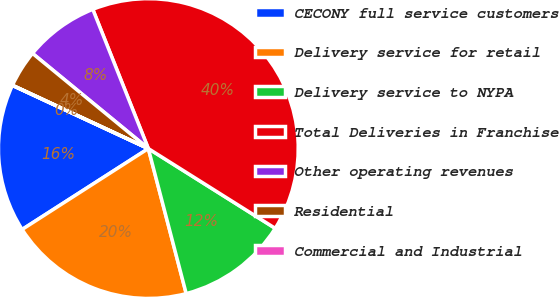<chart> <loc_0><loc_0><loc_500><loc_500><pie_chart><fcel>CECONY full service customers<fcel>Delivery service for retail<fcel>Delivery service to NYPA<fcel>Total Deliveries in Franchise<fcel>Other operating revenues<fcel>Residential<fcel>Commercial and Industrial<nl><fcel>16.0%<fcel>19.99%<fcel>12.0%<fcel>39.97%<fcel>8.01%<fcel>4.01%<fcel>0.01%<nl></chart> 